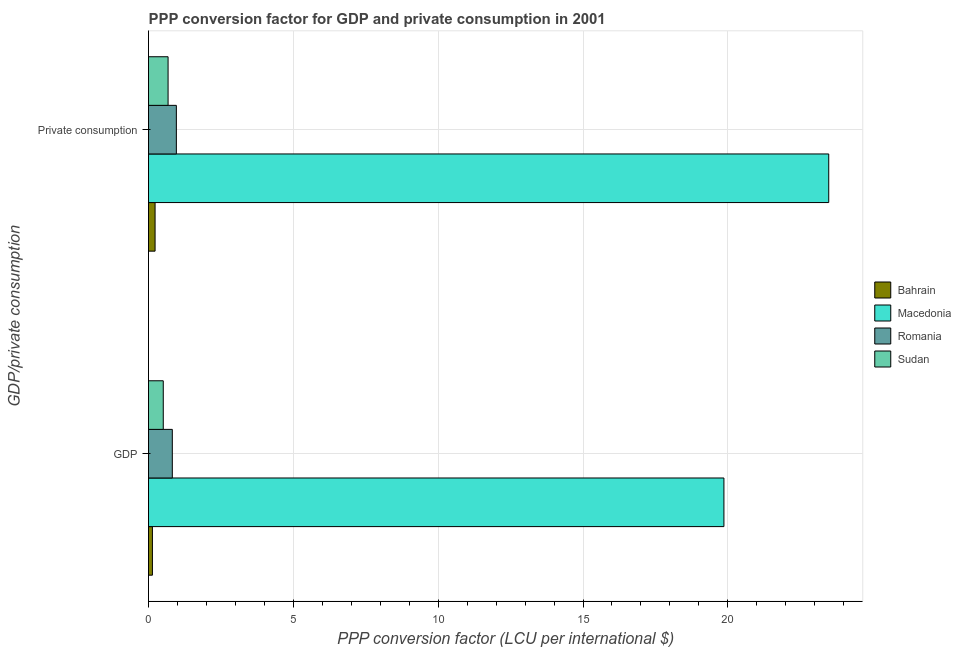How many groups of bars are there?
Your answer should be compact. 2. Are the number of bars per tick equal to the number of legend labels?
Provide a short and direct response. Yes. Are the number of bars on each tick of the Y-axis equal?
Your answer should be compact. Yes. What is the label of the 2nd group of bars from the top?
Your answer should be very brief. GDP. What is the ppp conversion factor for private consumption in Sudan?
Your answer should be compact. 0.68. Across all countries, what is the maximum ppp conversion factor for gdp?
Give a very brief answer. 19.86. Across all countries, what is the minimum ppp conversion factor for private consumption?
Your response must be concise. 0.23. In which country was the ppp conversion factor for gdp maximum?
Provide a short and direct response. Macedonia. In which country was the ppp conversion factor for gdp minimum?
Provide a succinct answer. Bahrain. What is the total ppp conversion factor for private consumption in the graph?
Keep it short and to the point. 25.35. What is the difference between the ppp conversion factor for gdp in Macedonia and that in Romania?
Provide a short and direct response. 19.04. What is the difference between the ppp conversion factor for private consumption in Macedonia and the ppp conversion factor for gdp in Romania?
Provide a succinct answer. 22.66. What is the average ppp conversion factor for private consumption per country?
Your answer should be compact. 6.34. What is the difference between the ppp conversion factor for gdp and ppp conversion factor for private consumption in Romania?
Offer a terse response. -0.14. What is the ratio of the ppp conversion factor for gdp in Macedonia to that in Romania?
Offer a terse response. 24.18. Is the ppp conversion factor for private consumption in Romania less than that in Sudan?
Provide a short and direct response. No. What does the 4th bar from the top in GDP represents?
Give a very brief answer. Bahrain. What does the 1st bar from the bottom in GDP represents?
Your response must be concise. Bahrain. Are the values on the major ticks of X-axis written in scientific E-notation?
Ensure brevity in your answer.  No. Does the graph contain any zero values?
Offer a very short reply. No. Does the graph contain grids?
Offer a terse response. Yes. Where does the legend appear in the graph?
Give a very brief answer. Center right. How are the legend labels stacked?
Your answer should be very brief. Vertical. What is the title of the graph?
Make the answer very short. PPP conversion factor for GDP and private consumption in 2001. What is the label or title of the X-axis?
Your answer should be very brief. PPP conversion factor (LCU per international $). What is the label or title of the Y-axis?
Provide a succinct answer. GDP/private consumption. What is the PPP conversion factor (LCU per international $) of Bahrain in GDP?
Offer a very short reply. 0.13. What is the PPP conversion factor (LCU per international $) of Macedonia in GDP?
Keep it short and to the point. 19.86. What is the PPP conversion factor (LCU per international $) in Romania in GDP?
Your response must be concise. 0.82. What is the PPP conversion factor (LCU per international $) in Sudan in GDP?
Provide a succinct answer. 0.51. What is the PPP conversion factor (LCU per international $) of Bahrain in  Private consumption?
Provide a short and direct response. 0.23. What is the PPP conversion factor (LCU per international $) of Macedonia in  Private consumption?
Your response must be concise. 23.48. What is the PPP conversion factor (LCU per international $) in Romania in  Private consumption?
Offer a very short reply. 0.96. What is the PPP conversion factor (LCU per international $) in Sudan in  Private consumption?
Provide a succinct answer. 0.68. Across all GDP/private consumption, what is the maximum PPP conversion factor (LCU per international $) in Bahrain?
Your response must be concise. 0.23. Across all GDP/private consumption, what is the maximum PPP conversion factor (LCU per international $) in Macedonia?
Your response must be concise. 23.48. Across all GDP/private consumption, what is the maximum PPP conversion factor (LCU per international $) of Romania?
Ensure brevity in your answer.  0.96. Across all GDP/private consumption, what is the maximum PPP conversion factor (LCU per international $) in Sudan?
Provide a short and direct response. 0.68. Across all GDP/private consumption, what is the minimum PPP conversion factor (LCU per international $) in Bahrain?
Ensure brevity in your answer.  0.13. Across all GDP/private consumption, what is the minimum PPP conversion factor (LCU per international $) in Macedonia?
Ensure brevity in your answer.  19.86. Across all GDP/private consumption, what is the minimum PPP conversion factor (LCU per international $) in Romania?
Offer a very short reply. 0.82. Across all GDP/private consumption, what is the minimum PPP conversion factor (LCU per international $) of Sudan?
Your response must be concise. 0.51. What is the total PPP conversion factor (LCU per international $) in Bahrain in the graph?
Make the answer very short. 0.36. What is the total PPP conversion factor (LCU per international $) of Macedonia in the graph?
Provide a short and direct response. 43.35. What is the total PPP conversion factor (LCU per international $) in Romania in the graph?
Give a very brief answer. 1.78. What is the total PPP conversion factor (LCU per international $) in Sudan in the graph?
Offer a very short reply. 1.18. What is the difference between the PPP conversion factor (LCU per international $) in Bahrain in GDP and that in  Private consumption?
Make the answer very short. -0.09. What is the difference between the PPP conversion factor (LCU per international $) of Macedonia in GDP and that in  Private consumption?
Offer a very short reply. -3.62. What is the difference between the PPP conversion factor (LCU per international $) in Romania in GDP and that in  Private consumption?
Provide a short and direct response. -0.14. What is the difference between the PPP conversion factor (LCU per international $) in Sudan in GDP and that in  Private consumption?
Provide a short and direct response. -0.17. What is the difference between the PPP conversion factor (LCU per international $) of Bahrain in GDP and the PPP conversion factor (LCU per international $) of Macedonia in  Private consumption?
Your answer should be very brief. -23.35. What is the difference between the PPP conversion factor (LCU per international $) in Bahrain in GDP and the PPP conversion factor (LCU per international $) in Romania in  Private consumption?
Your response must be concise. -0.83. What is the difference between the PPP conversion factor (LCU per international $) of Bahrain in GDP and the PPP conversion factor (LCU per international $) of Sudan in  Private consumption?
Provide a short and direct response. -0.54. What is the difference between the PPP conversion factor (LCU per international $) of Macedonia in GDP and the PPP conversion factor (LCU per international $) of Romania in  Private consumption?
Your answer should be very brief. 18.9. What is the difference between the PPP conversion factor (LCU per international $) in Macedonia in GDP and the PPP conversion factor (LCU per international $) in Sudan in  Private consumption?
Keep it short and to the point. 19.19. What is the difference between the PPP conversion factor (LCU per international $) in Romania in GDP and the PPP conversion factor (LCU per international $) in Sudan in  Private consumption?
Your response must be concise. 0.15. What is the average PPP conversion factor (LCU per international $) in Bahrain per GDP/private consumption?
Ensure brevity in your answer.  0.18. What is the average PPP conversion factor (LCU per international $) in Macedonia per GDP/private consumption?
Provide a succinct answer. 21.67. What is the average PPP conversion factor (LCU per international $) of Romania per GDP/private consumption?
Provide a succinct answer. 0.89. What is the average PPP conversion factor (LCU per international $) of Sudan per GDP/private consumption?
Your answer should be very brief. 0.59. What is the difference between the PPP conversion factor (LCU per international $) of Bahrain and PPP conversion factor (LCU per international $) of Macedonia in GDP?
Your answer should be compact. -19.73. What is the difference between the PPP conversion factor (LCU per international $) in Bahrain and PPP conversion factor (LCU per international $) in Romania in GDP?
Make the answer very short. -0.69. What is the difference between the PPP conversion factor (LCU per international $) in Bahrain and PPP conversion factor (LCU per international $) in Sudan in GDP?
Your answer should be compact. -0.37. What is the difference between the PPP conversion factor (LCU per international $) of Macedonia and PPP conversion factor (LCU per international $) of Romania in GDP?
Keep it short and to the point. 19.04. What is the difference between the PPP conversion factor (LCU per international $) in Macedonia and PPP conversion factor (LCU per international $) in Sudan in GDP?
Give a very brief answer. 19.36. What is the difference between the PPP conversion factor (LCU per international $) of Romania and PPP conversion factor (LCU per international $) of Sudan in GDP?
Provide a succinct answer. 0.31. What is the difference between the PPP conversion factor (LCU per international $) of Bahrain and PPP conversion factor (LCU per international $) of Macedonia in  Private consumption?
Give a very brief answer. -23.26. What is the difference between the PPP conversion factor (LCU per international $) in Bahrain and PPP conversion factor (LCU per international $) in Romania in  Private consumption?
Offer a terse response. -0.73. What is the difference between the PPP conversion factor (LCU per international $) of Bahrain and PPP conversion factor (LCU per international $) of Sudan in  Private consumption?
Your answer should be compact. -0.45. What is the difference between the PPP conversion factor (LCU per international $) in Macedonia and PPP conversion factor (LCU per international $) in Romania in  Private consumption?
Provide a succinct answer. 22.52. What is the difference between the PPP conversion factor (LCU per international $) of Macedonia and PPP conversion factor (LCU per international $) of Sudan in  Private consumption?
Your answer should be compact. 22.81. What is the difference between the PPP conversion factor (LCU per international $) in Romania and PPP conversion factor (LCU per international $) in Sudan in  Private consumption?
Offer a terse response. 0.29. What is the ratio of the PPP conversion factor (LCU per international $) in Bahrain in GDP to that in  Private consumption?
Give a very brief answer. 0.6. What is the ratio of the PPP conversion factor (LCU per international $) in Macedonia in GDP to that in  Private consumption?
Keep it short and to the point. 0.85. What is the ratio of the PPP conversion factor (LCU per international $) in Romania in GDP to that in  Private consumption?
Provide a short and direct response. 0.85. What is the ratio of the PPP conversion factor (LCU per international $) in Sudan in GDP to that in  Private consumption?
Provide a short and direct response. 0.75. What is the difference between the highest and the second highest PPP conversion factor (LCU per international $) of Bahrain?
Give a very brief answer. 0.09. What is the difference between the highest and the second highest PPP conversion factor (LCU per international $) of Macedonia?
Keep it short and to the point. 3.62. What is the difference between the highest and the second highest PPP conversion factor (LCU per international $) in Romania?
Provide a succinct answer. 0.14. What is the difference between the highest and the second highest PPP conversion factor (LCU per international $) of Sudan?
Your response must be concise. 0.17. What is the difference between the highest and the lowest PPP conversion factor (LCU per international $) in Bahrain?
Your answer should be compact. 0.09. What is the difference between the highest and the lowest PPP conversion factor (LCU per international $) in Macedonia?
Keep it short and to the point. 3.62. What is the difference between the highest and the lowest PPP conversion factor (LCU per international $) of Romania?
Make the answer very short. 0.14. What is the difference between the highest and the lowest PPP conversion factor (LCU per international $) in Sudan?
Ensure brevity in your answer.  0.17. 